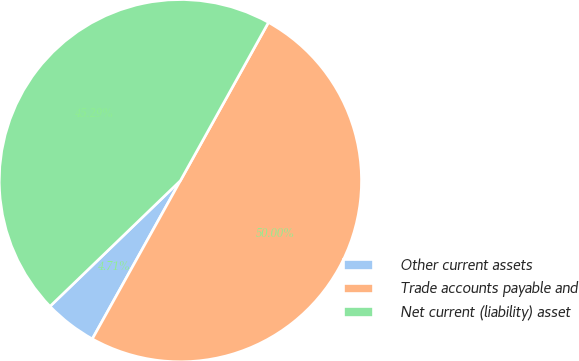<chart> <loc_0><loc_0><loc_500><loc_500><pie_chart><fcel>Other current assets<fcel>Trade accounts payable and<fcel>Net current (liability) asset<nl><fcel>4.71%<fcel>50.0%<fcel>45.29%<nl></chart> 